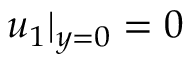<formula> <loc_0><loc_0><loc_500><loc_500>u _ { 1 } | _ { y = 0 } = 0</formula> 